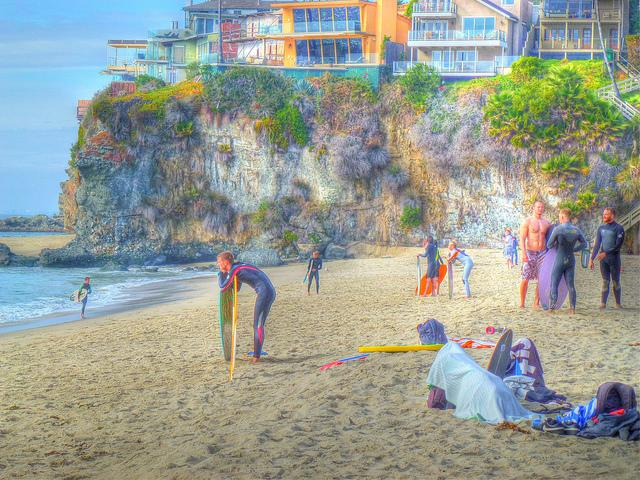What is this image? Please explain your reasoning. drawing. You can see the brush strokes 